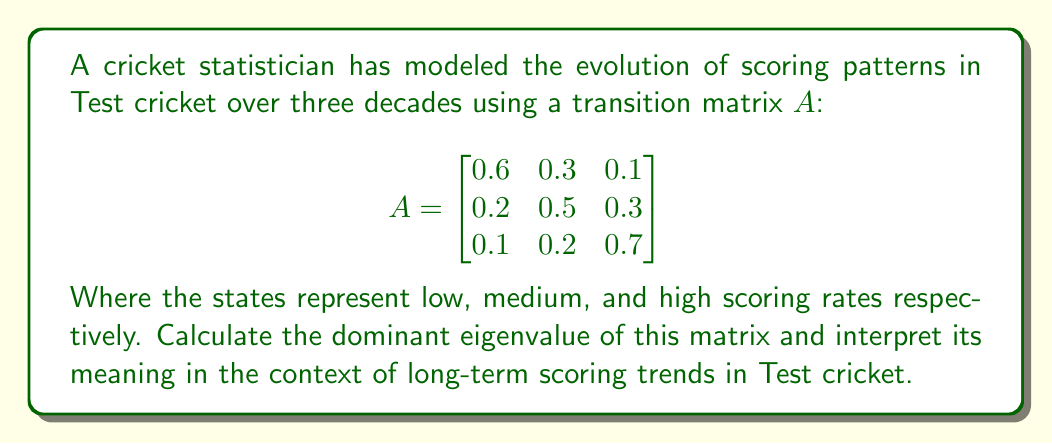Provide a solution to this math problem. To find the dominant eigenvalue and interpret its meaning, we'll follow these steps:

1) First, we need to find the eigenvalues of matrix $A$. The characteristic equation is:

   $det(A - \lambda I) = 0$

   $\begin{vmatrix}
   0.6-\lambda & 0.3 & 0.1 \\
   0.2 & 0.5-\lambda & 0.3 \\
   0.1 & 0.2 & 0.7-\lambda
   \end{vmatrix} = 0$

2) Expanding this determinant:

   $(0.6-\lambda)[(0.5-\lambda)(0.7-\lambda)-0.06] - 0.3[0.2(0.7-\lambda)-0.03] + 0.1[0.2(0.5-\lambda)-0.06] = 0$

3) Simplifying:

   $-\lambda^3 + 1.8\lambda^2 - 0.98\lambda + 0.162 = 0$

4) Solving this cubic equation (using a calculator or computer algebra system), we get:

   $\lambda_1 \approx 1$
   $\lambda_2 \approx 0.4$
   $\lambda_3 \approx 0.4$

5) The dominant eigenvalue is the one with the largest absolute value, which is $\lambda_1 \approx 1$.

6) Interpretation: In the context of long-term scoring trends in Test cricket, the dominant eigenvalue being approximately 1 suggests that the scoring pattern distribution will reach a stable equilibrium over time. This means that the proportion of low, medium, and high scoring rates will eventually settle into a consistent pattern, rather than continually shifting or oscillating.
Answer: $\lambda_1 \approx 1$, indicating long-term stability in scoring pattern distribution. 